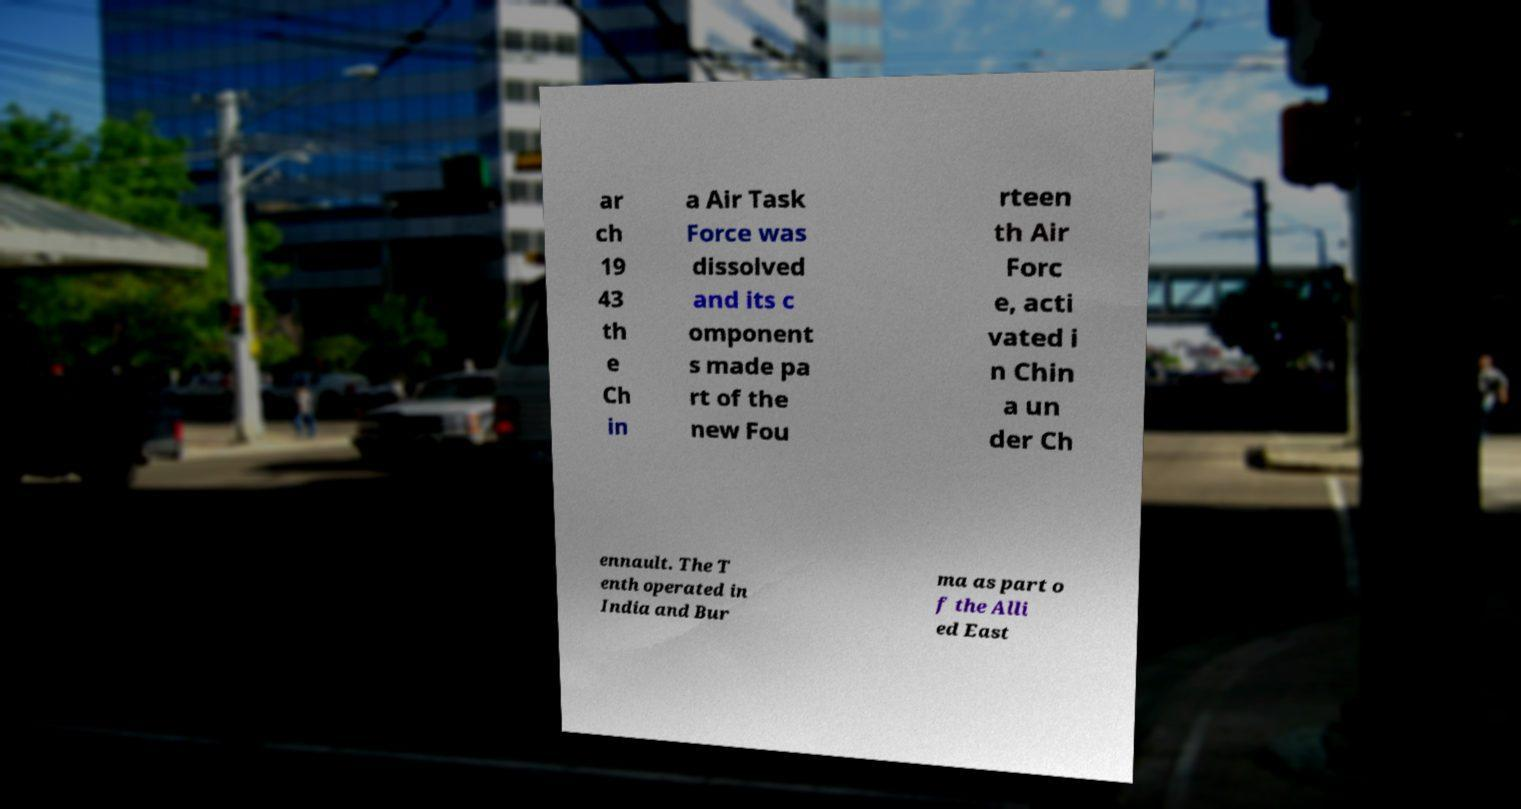Please read and relay the text visible in this image. What does it say? ar ch 19 43 th e Ch in a Air Task Force was dissolved and its c omponent s made pa rt of the new Fou rteen th Air Forc e, acti vated i n Chin a un der Ch ennault. The T enth operated in India and Bur ma as part o f the Alli ed East 